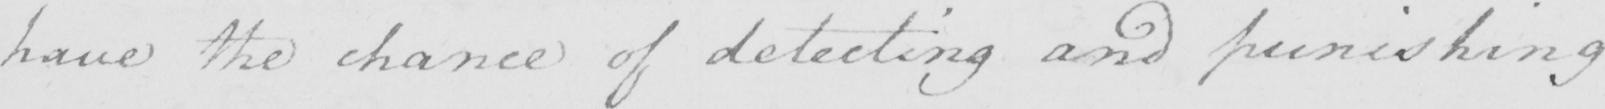What is written in this line of handwriting? have the chance of detecting and punishing 